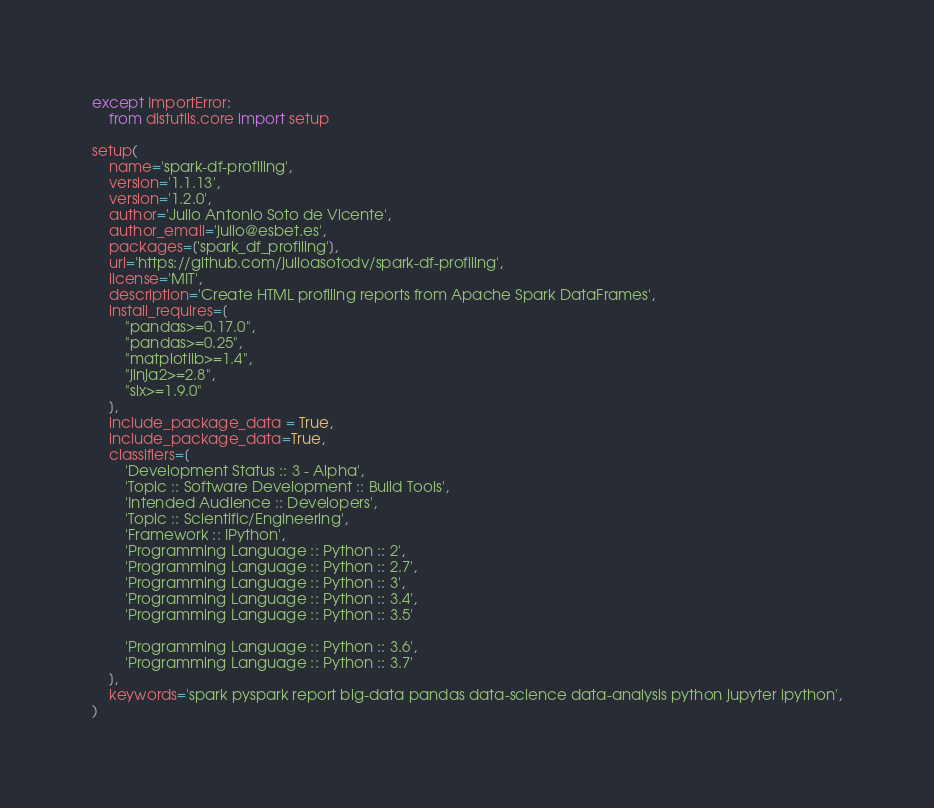Convert code to text. <code><loc_0><loc_0><loc_500><loc_500><_Python_>except ImportError:
    from distutils.core import setup

setup(
    name='spark-df-profiling',
    version='1.1.13',
    version='1.2.0',
    author='Julio Antonio Soto de Vicente',
    author_email='julio@esbet.es',
    packages=['spark_df_profiling'],
    url='https://github.com/julioasotodv/spark-df-profiling',
    license='MIT',
    description='Create HTML profiling reports from Apache Spark DataFrames',
    install_requires=[
        "pandas>=0.17.0",
        "pandas>=0.25",
        "matplotlib>=1.4",
        "jinja2>=2.8",
        "six>=1.9.0"
    ],
    include_package_data = True,
    include_package_data=True,
    classifiers=[
        'Development Status :: 3 - Alpha',
        'Topic :: Software Development :: Build Tools',
        'Intended Audience :: Developers',
        'Topic :: Scientific/Engineering',
        'Framework :: IPython',
        'Programming Language :: Python :: 2',
        'Programming Language :: Python :: 2.7',
        'Programming Language :: Python :: 3',
        'Programming Language :: Python :: 3.4',
        'Programming Language :: Python :: 3.5'

        'Programming Language :: Python :: 3.6',
        'Programming Language :: Python :: 3.7'
    ],
    keywords='spark pyspark report big-data pandas data-science data-analysis python jupyter ipython',
)</code> 